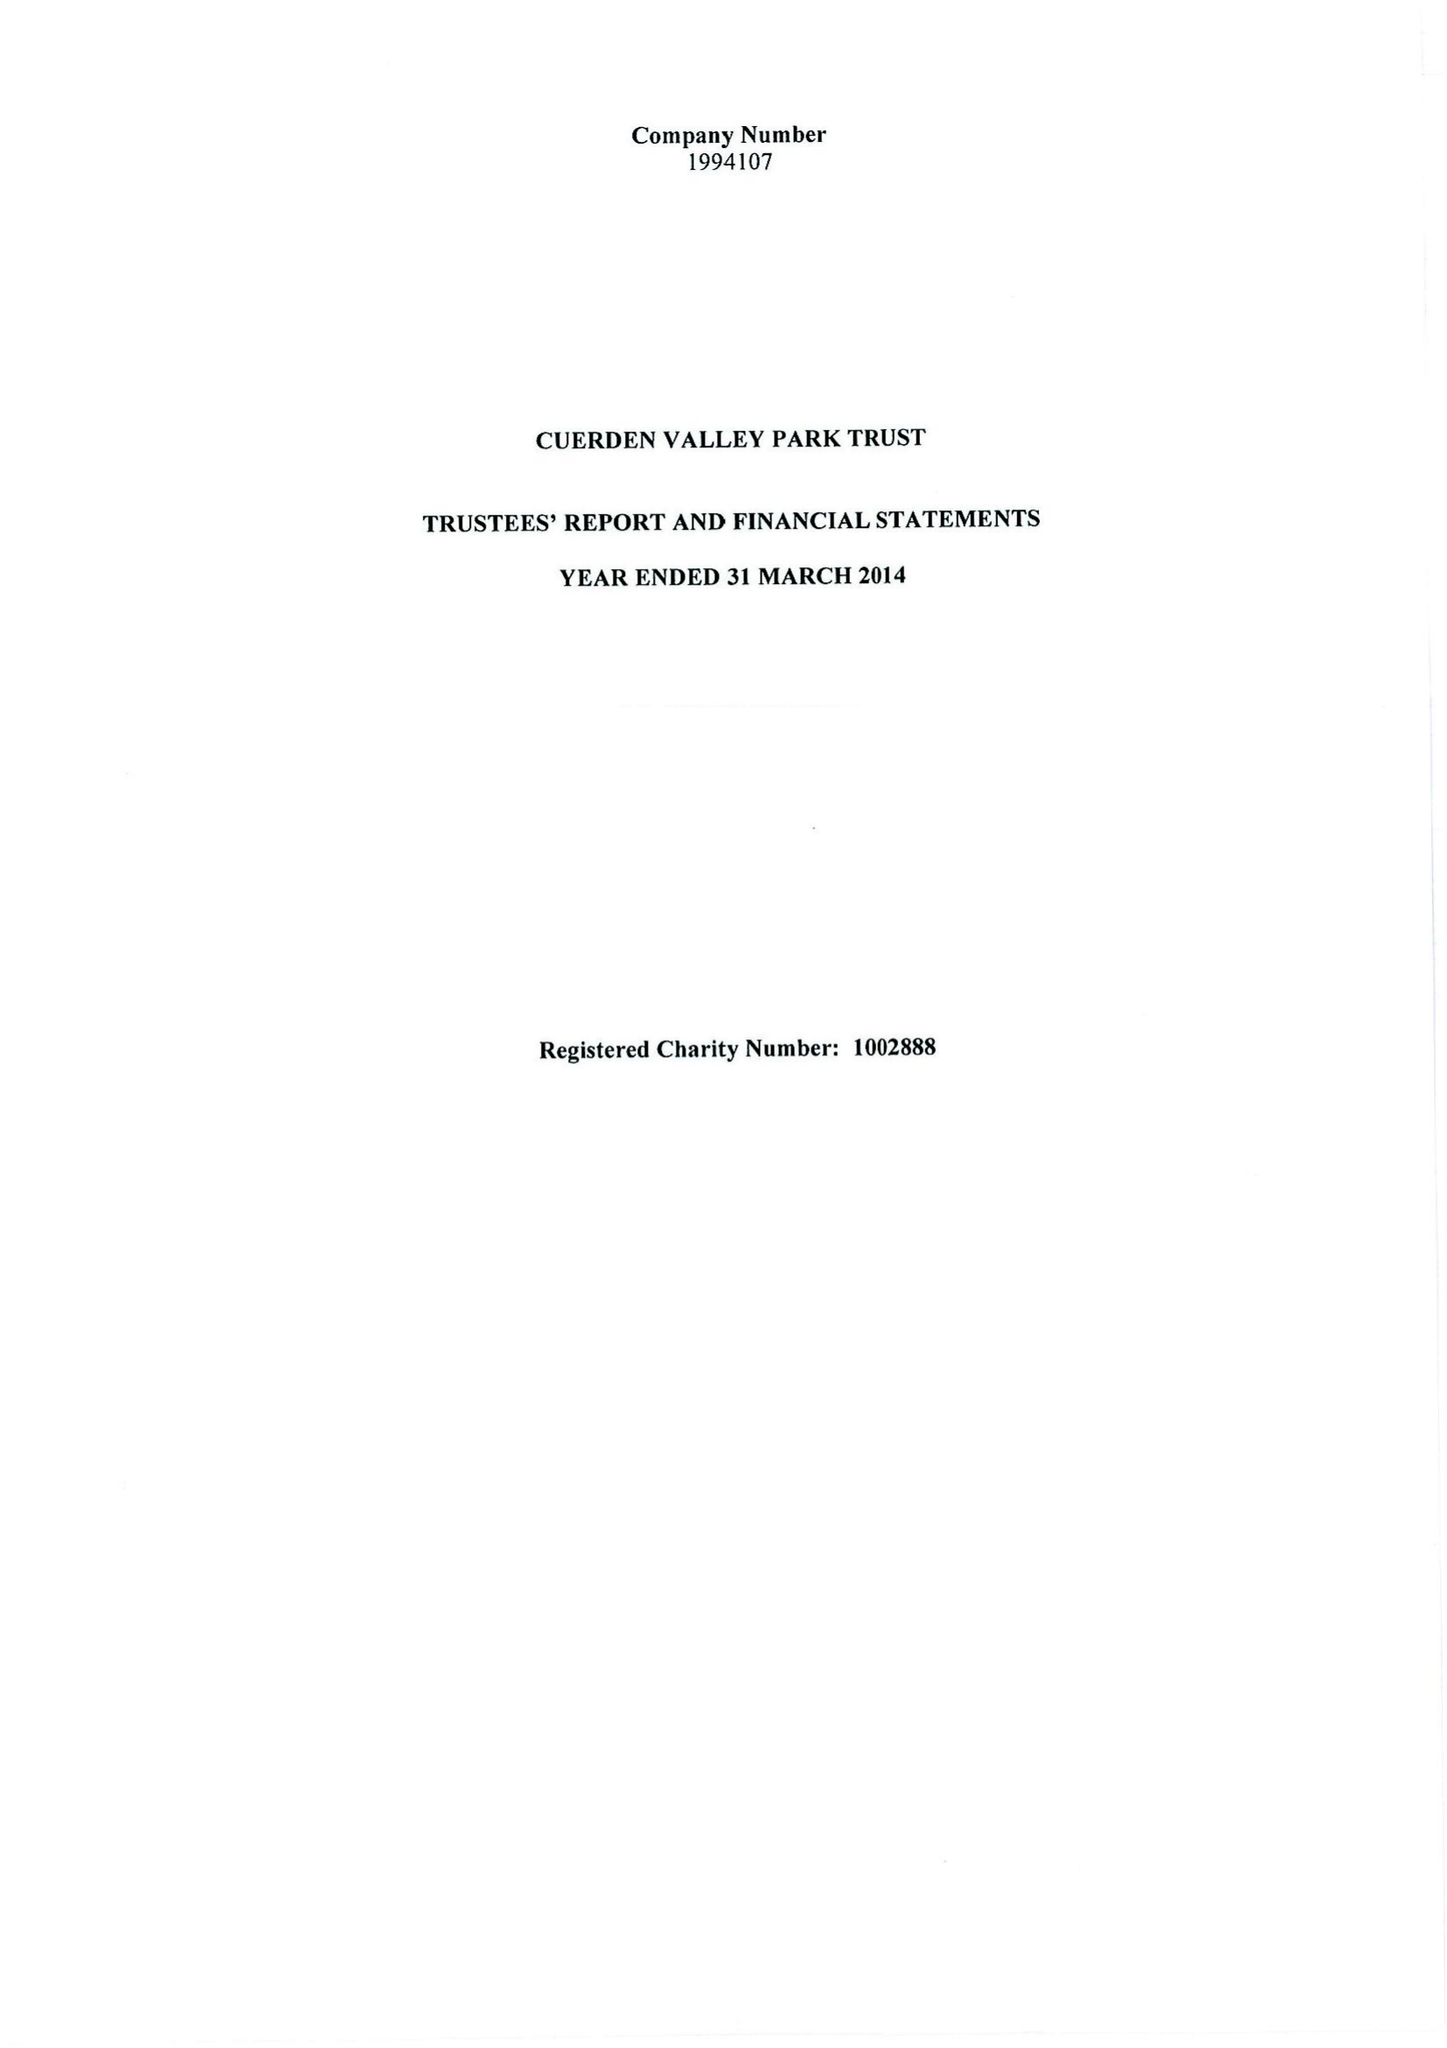What is the value for the report_date?
Answer the question using a single word or phrase. 2014-03-31 